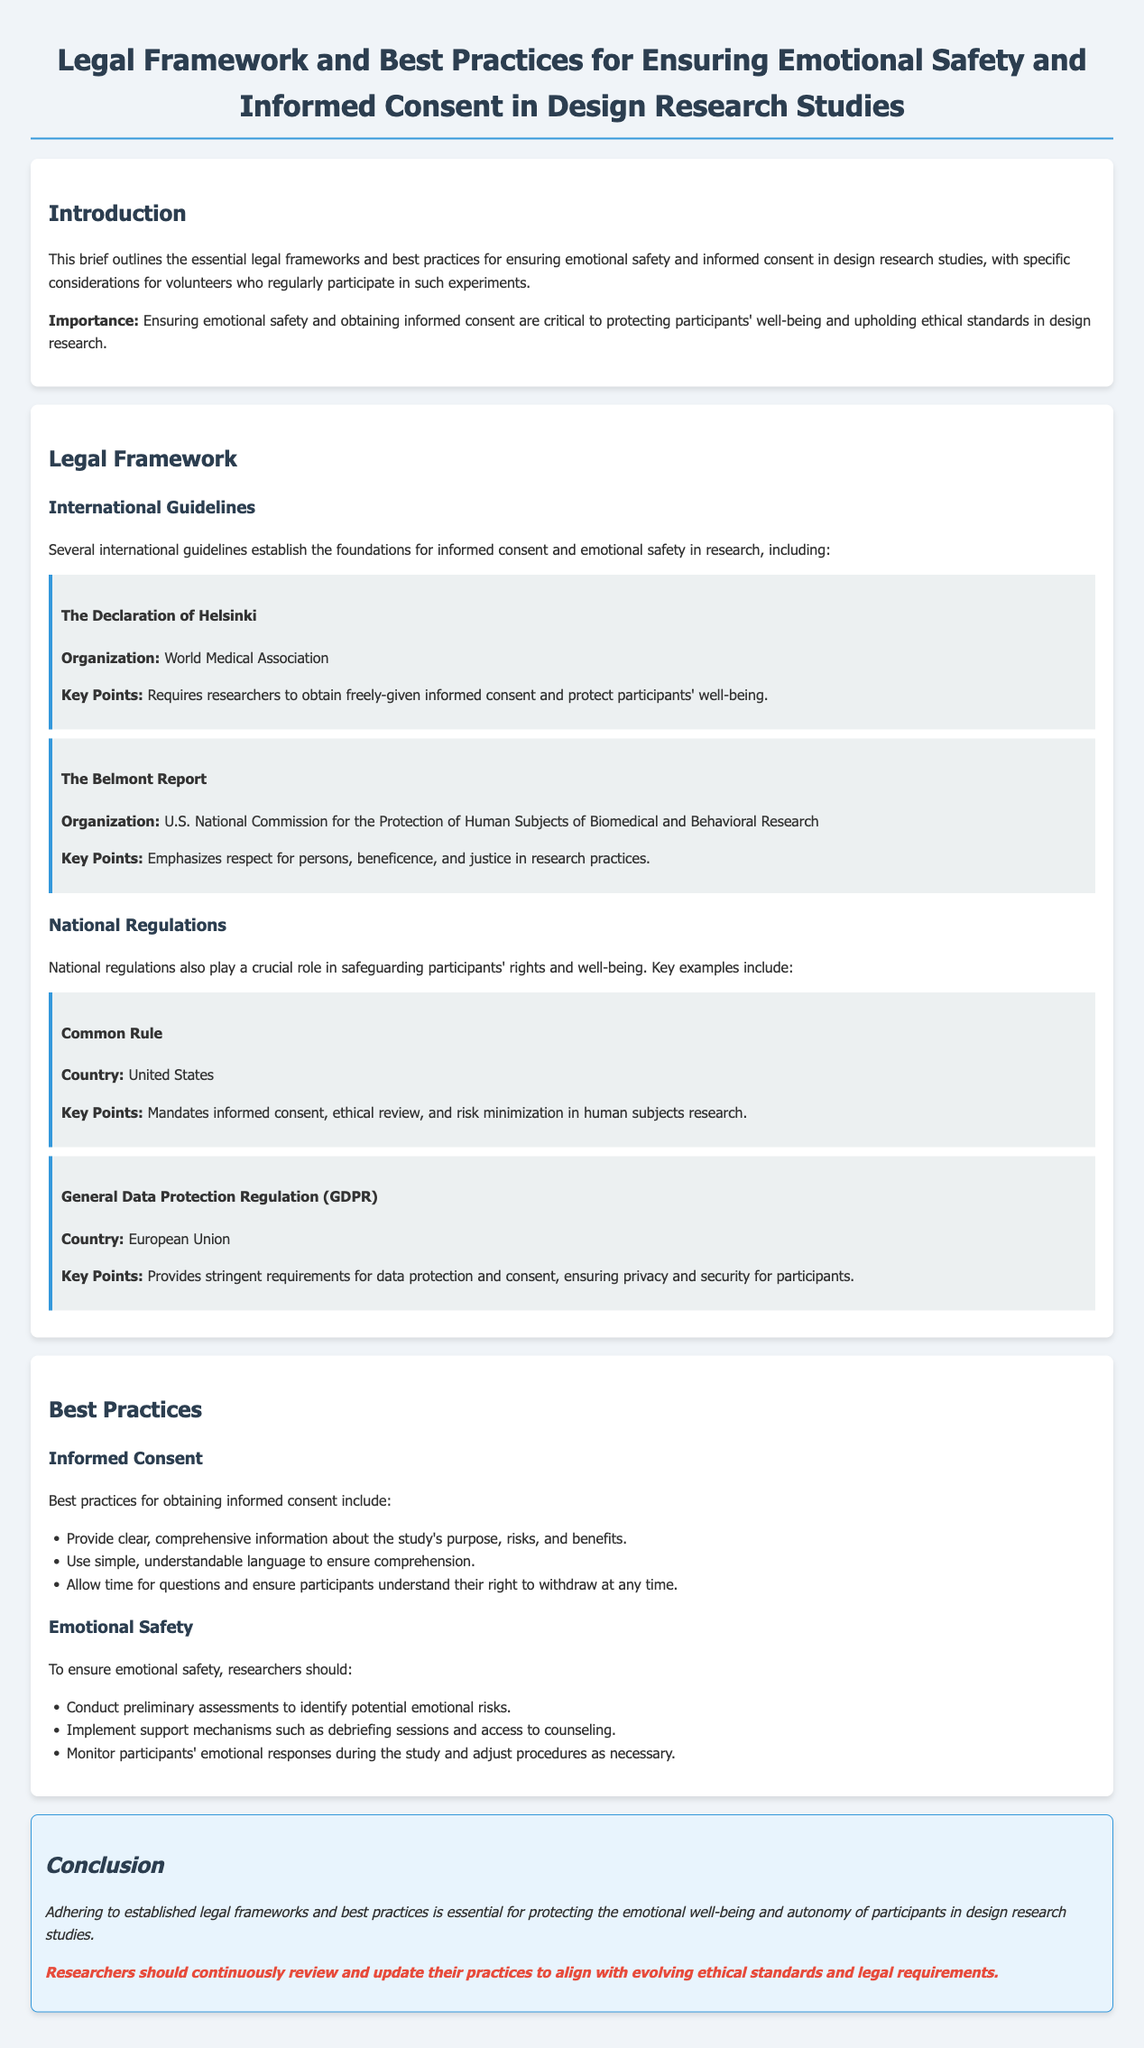what organization created the Declaration of Helsinki? The Declaration of Helsinki is established by the World Medical Association, which is mentioned in the document.
Answer: World Medical Association what key principle does the Belmont Report emphasize? The Belmont Report emphasizes respect for persons, beneficence, and justice, which are highlighted in the document.
Answer: Respect for persons what regulation mandates informed consent in human subjects research? The document points out that the Common Rule mandates informed consent, among other ethical requirements.
Answer: Common Rule which regulation provides requirements for data protection in the EU? The General Data Protection Regulation (GDPR) is mentioned in the document as the regulation that provides data protection requirements.
Answer: GDPR what is one of the best practices for obtaining informed consent? One of the best practices mentioned is providing clear, comprehensive information about the study's purpose, risks, and benefits.
Answer: Clear information what should researchers implement to ensure emotional safety? The document states that researchers should implement support mechanisms such as debriefing sessions and access to counseling to ensure emotional safety.
Answer: Debriefing sessions why is informed consent critical in design research? The document states that informed consent is critical for protecting participants' well-being and upholding ethical standards.
Answer: Protecting well-being what is the implication of the call-to-action in the conclusion? The conclusion emphasizes that researchers should continuously review and update their practices to align with evolving ethical standards and legal requirements.
Answer: Continuous review 